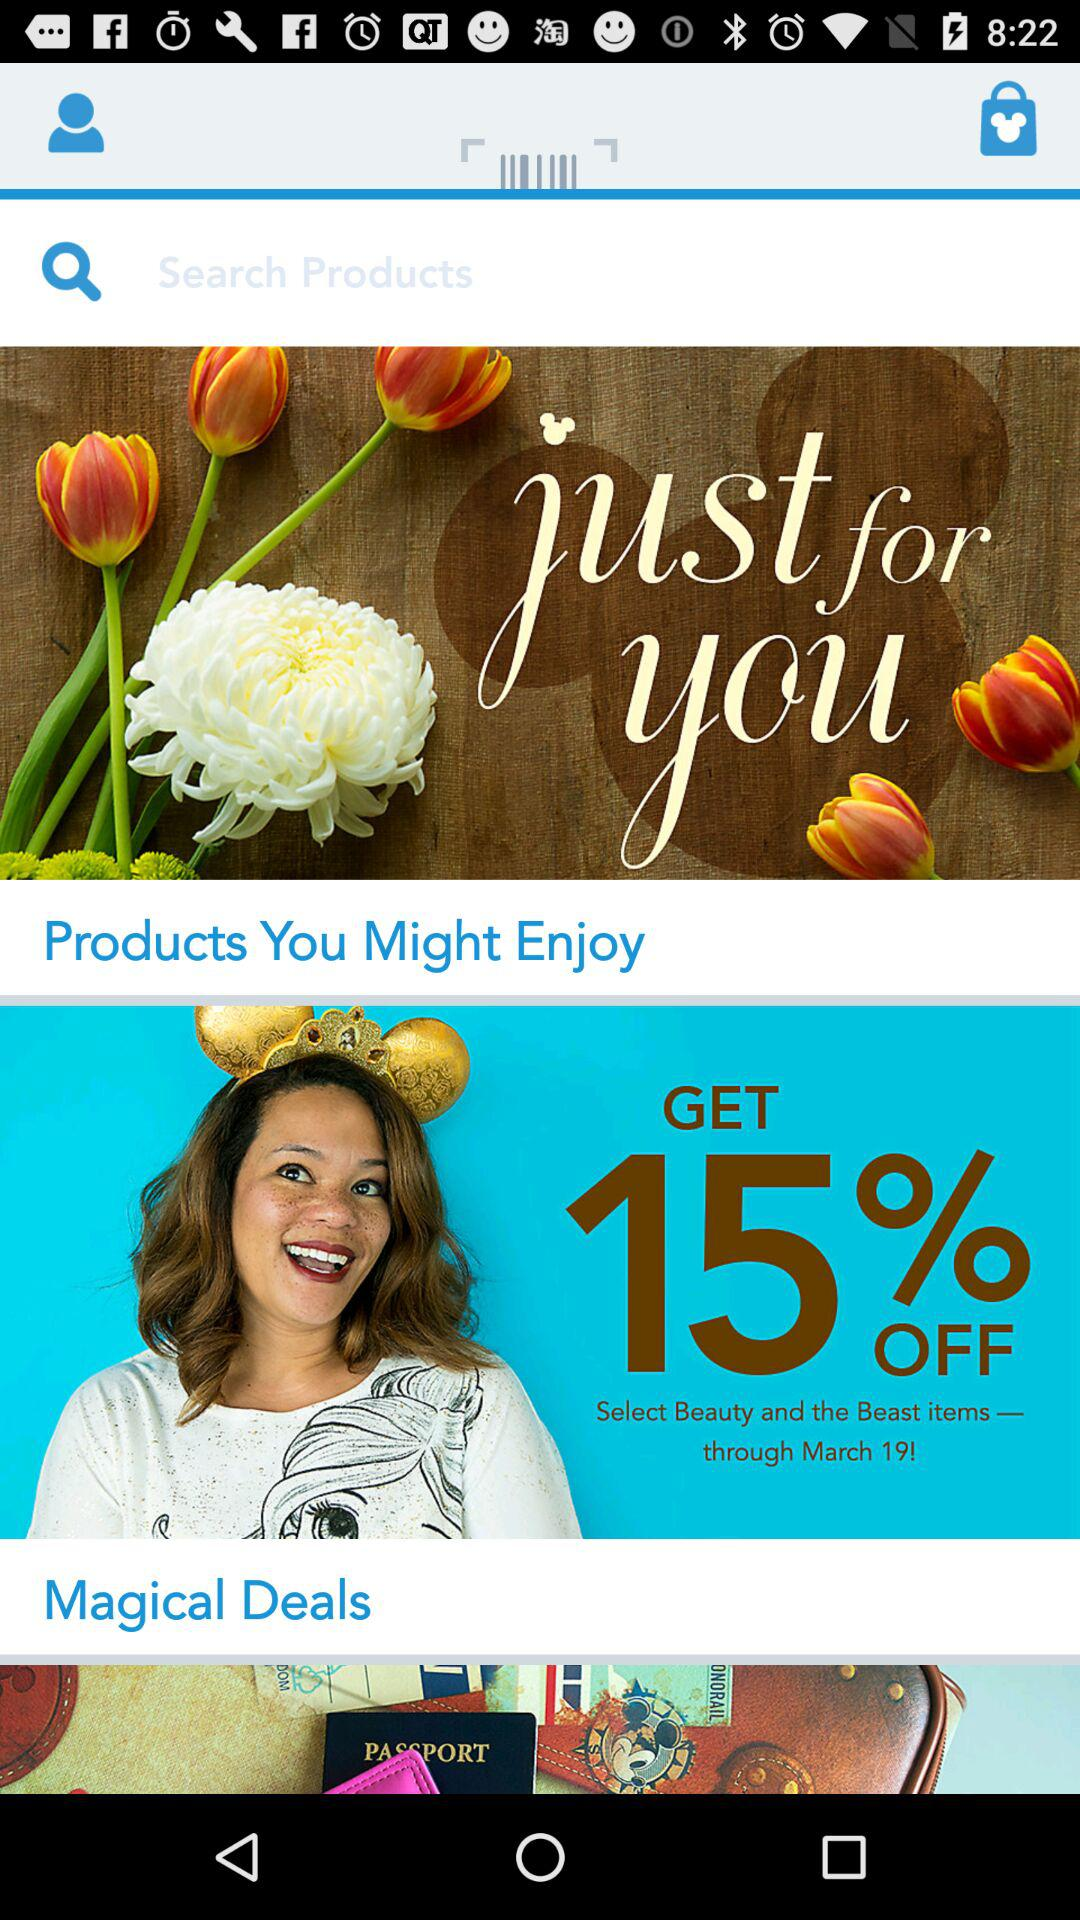How many items are in the shopping bag?
Answer the question using a single word or phrase. 0 